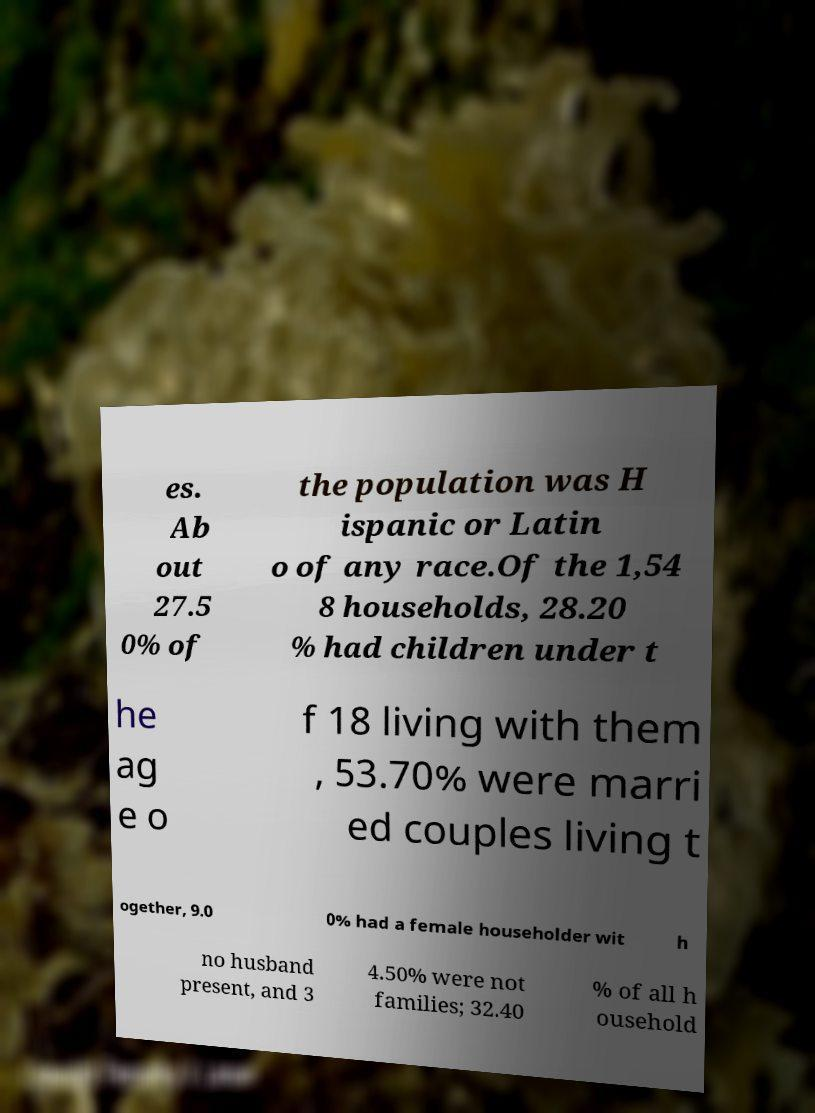Please identify and transcribe the text found in this image. es. Ab out 27.5 0% of the population was H ispanic or Latin o of any race.Of the 1,54 8 households, 28.20 % had children under t he ag e o f 18 living with them , 53.70% were marri ed couples living t ogether, 9.0 0% had a female householder wit h no husband present, and 3 4.50% were not families; 32.40 % of all h ousehold 